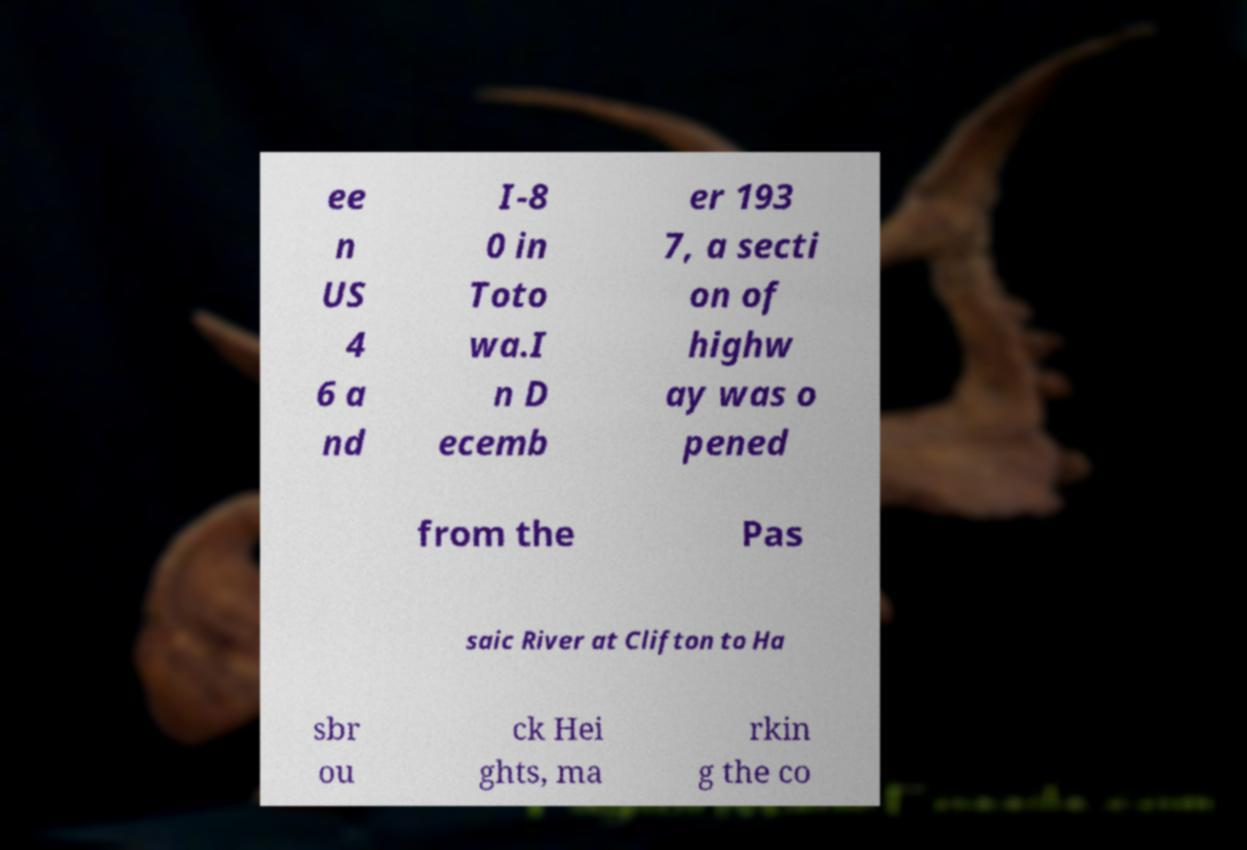Can you read and provide the text displayed in the image?This photo seems to have some interesting text. Can you extract and type it out for me? ee n US 4 6 a nd I-8 0 in Toto wa.I n D ecemb er 193 7, a secti on of highw ay was o pened from the Pas saic River at Clifton to Ha sbr ou ck Hei ghts, ma rkin g the co 